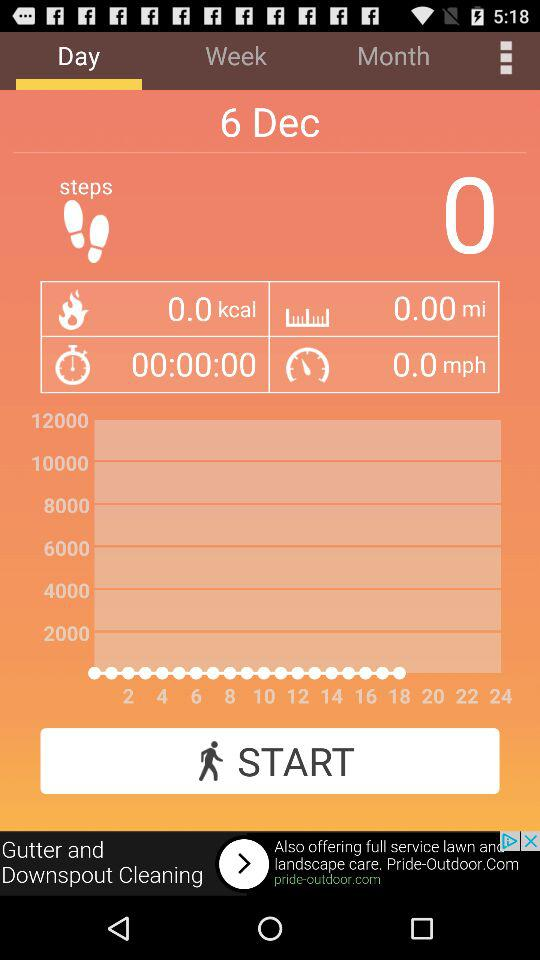What is the date? The date is December 6. 